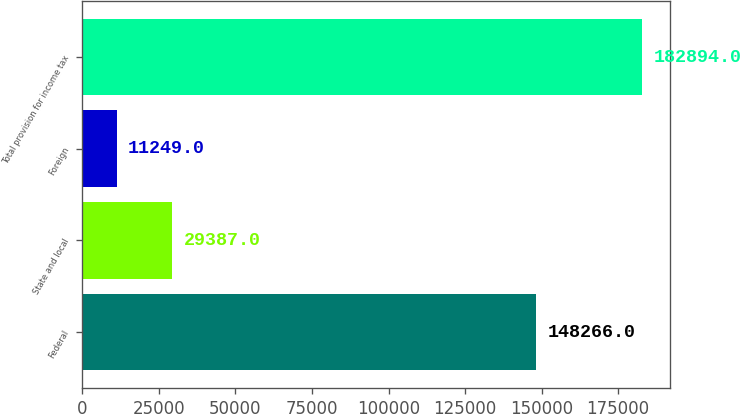Convert chart. <chart><loc_0><loc_0><loc_500><loc_500><bar_chart><fcel>Federal<fcel>State and local<fcel>Foreign<fcel>Total provision for income tax<nl><fcel>148266<fcel>29387<fcel>11249<fcel>182894<nl></chart> 